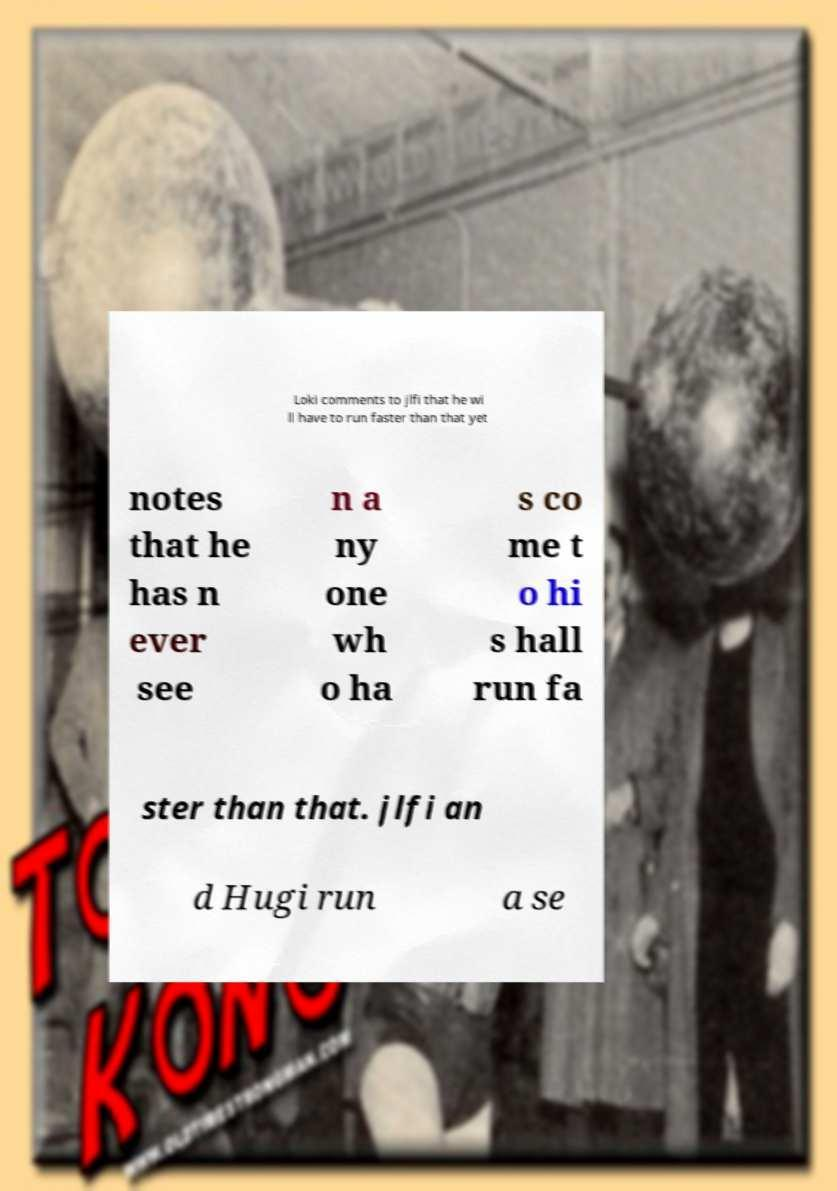Can you accurately transcribe the text from the provided image for me? Loki comments to jlfi that he wi ll have to run faster than that yet notes that he has n ever see n a ny one wh o ha s co me t o hi s hall run fa ster than that. jlfi an d Hugi run a se 